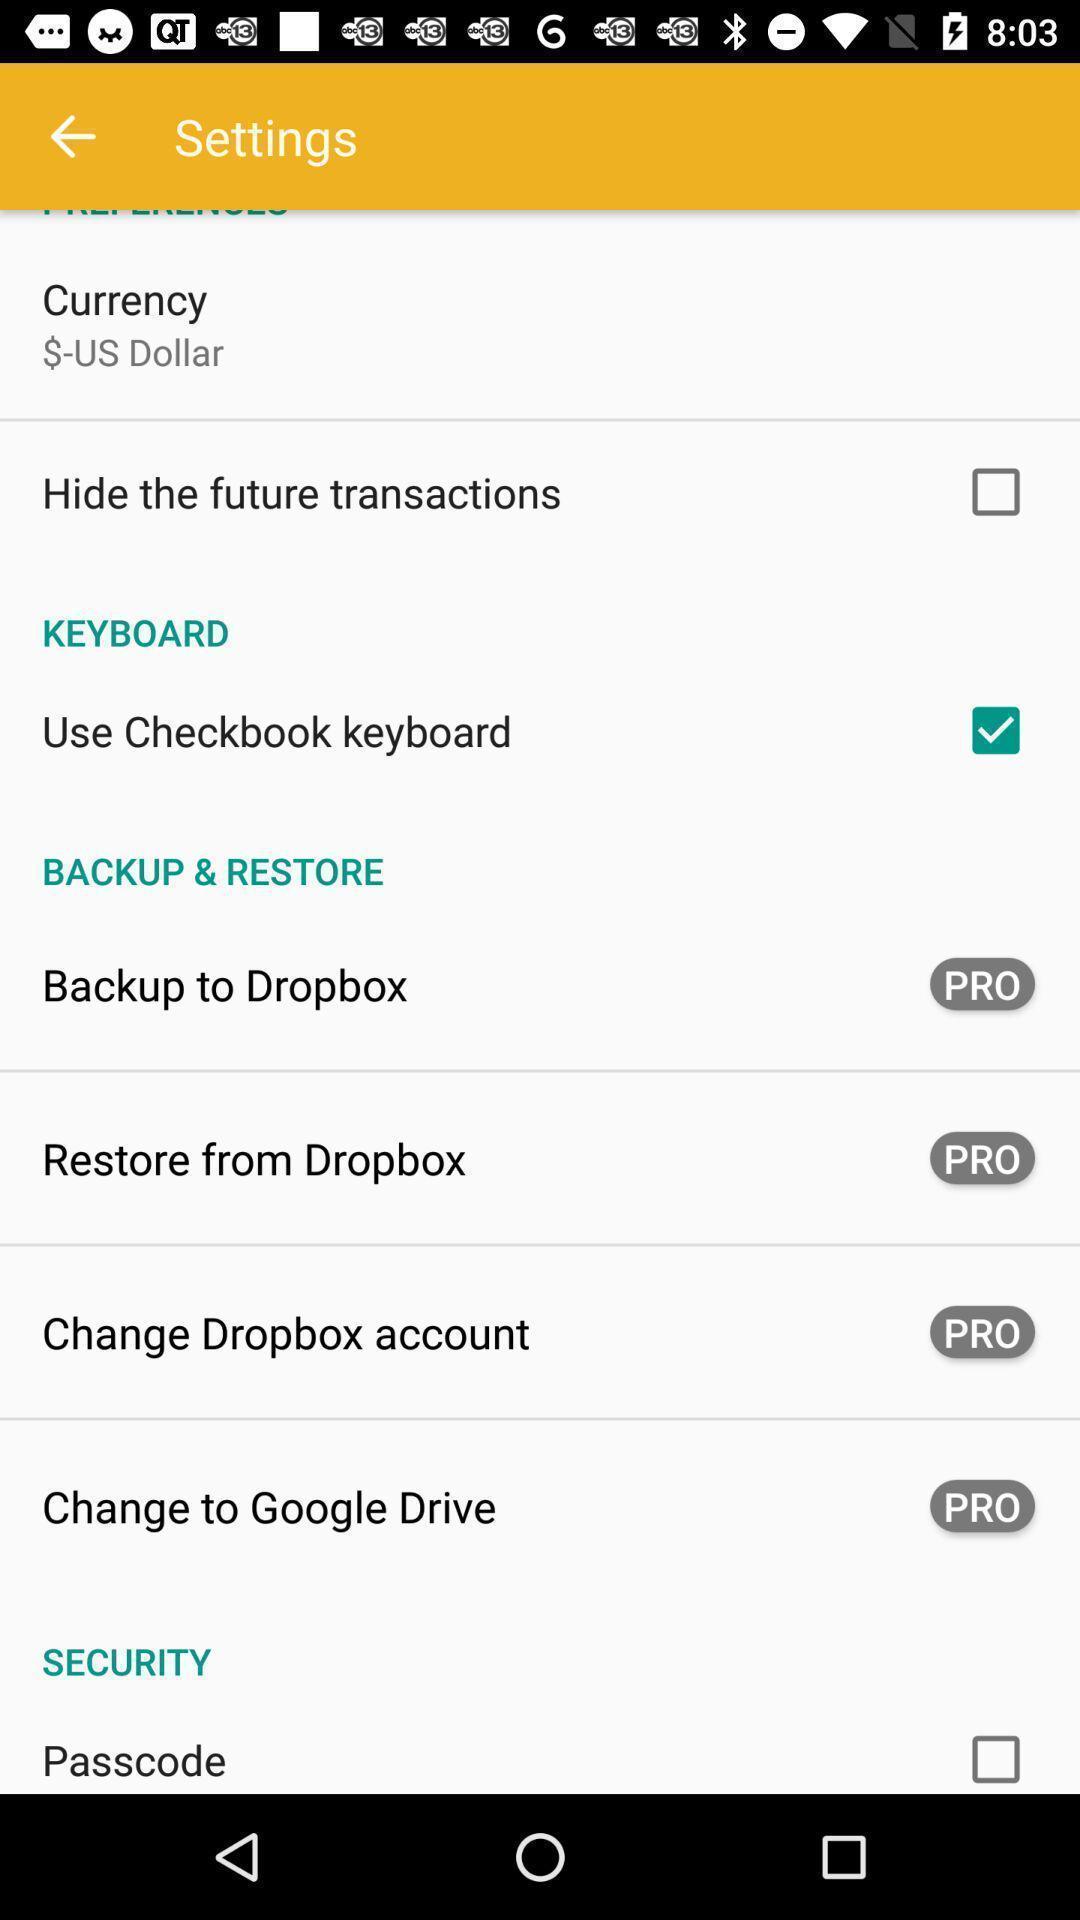Explain the elements present in this screenshot. Setting page displaying various options. 